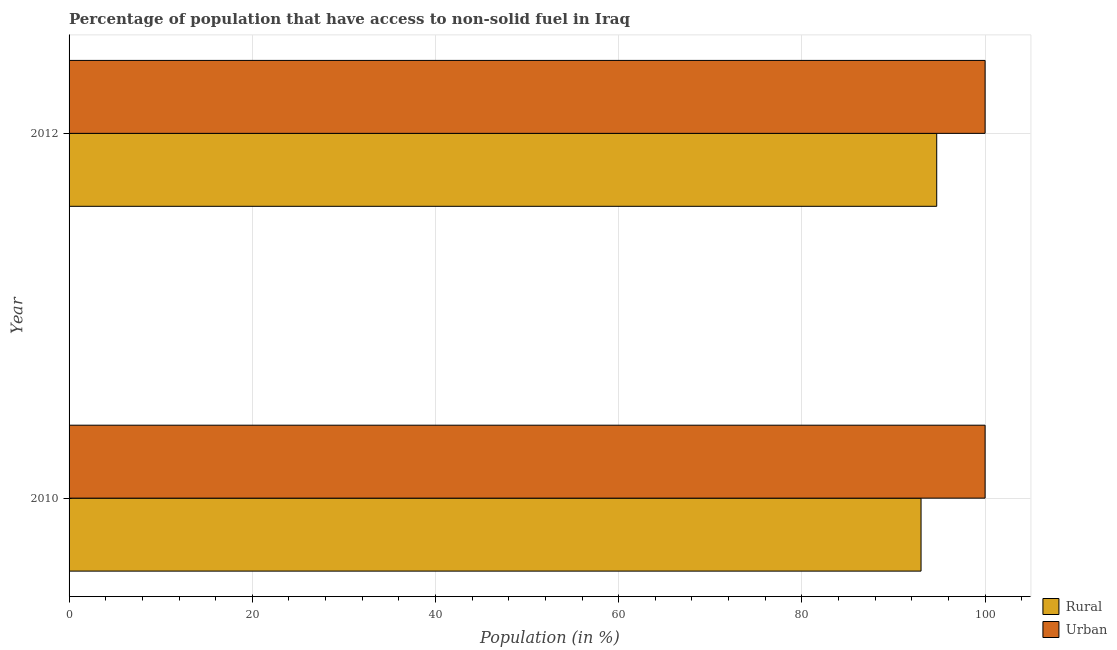How many different coloured bars are there?
Give a very brief answer. 2. How many groups of bars are there?
Make the answer very short. 2. Are the number of bars per tick equal to the number of legend labels?
Keep it short and to the point. Yes. Are the number of bars on each tick of the Y-axis equal?
Keep it short and to the point. Yes. In how many cases, is the number of bars for a given year not equal to the number of legend labels?
Give a very brief answer. 0. What is the urban population in 2012?
Provide a short and direct response. 100. Across all years, what is the maximum rural population?
Ensure brevity in your answer.  94.72. Across all years, what is the minimum urban population?
Provide a short and direct response. 100. In which year was the rural population minimum?
Offer a terse response. 2010. What is the total urban population in the graph?
Your response must be concise. 200. What is the difference between the rural population in 2010 and that in 2012?
Offer a terse response. -1.71. What is the difference between the rural population in 2010 and the urban population in 2012?
Make the answer very short. -6.99. In the year 2010, what is the difference between the urban population and rural population?
Give a very brief answer. 6.99. In how many years, is the rural population greater than 60 %?
Your answer should be compact. 2. What is the ratio of the rural population in 2010 to that in 2012?
Give a very brief answer. 0.98. Is the urban population in 2010 less than that in 2012?
Your answer should be very brief. No. In how many years, is the rural population greater than the average rural population taken over all years?
Your answer should be compact. 1. What does the 2nd bar from the top in 2010 represents?
Offer a terse response. Rural. What does the 2nd bar from the bottom in 2012 represents?
Offer a very short reply. Urban. How many bars are there?
Provide a succinct answer. 4. Does the graph contain grids?
Provide a short and direct response. Yes. How many legend labels are there?
Your answer should be very brief. 2. What is the title of the graph?
Keep it short and to the point. Percentage of population that have access to non-solid fuel in Iraq. Does "Female labourers" appear as one of the legend labels in the graph?
Your answer should be compact. No. What is the label or title of the X-axis?
Provide a succinct answer. Population (in %). What is the Population (in %) of Rural in 2010?
Your answer should be compact. 93.01. What is the Population (in %) of Urban in 2010?
Offer a terse response. 100. What is the Population (in %) of Rural in 2012?
Ensure brevity in your answer.  94.72. What is the Population (in %) in Urban in 2012?
Offer a very short reply. 100. Across all years, what is the maximum Population (in %) in Rural?
Provide a succinct answer. 94.72. Across all years, what is the minimum Population (in %) of Rural?
Your answer should be very brief. 93.01. What is the total Population (in %) of Rural in the graph?
Make the answer very short. 187.72. What is the total Population (in %) of Urban in the graph?
Offer a very short reply. 200. What is the difference between the Population (in %) of Rural in 2010 and that in 2012?
Your answer should be very brief. -1.71. What is the difference between the Population (in %) in Urban in 2010 and that in 2012?
Offer a very short reply. 0. What is the difference between the Population (in %) of Rural in 2010 and the Population (in %) of Urban in 2012?
Ensure brevity in your answer.  -6.99. What is the average Population (in %) of Rural per year?
Your response must be concise. 93.86. What is the average Population (in %) in Urban per year?
Offer a very short reply. 100. In the year 2010, what is the difference between the Population (in %) in Rural and Population (in %) in Urban?
Keep it short and to the point. -6.99. In the year 2012, what is the difference between the Population (in %) in Rural and Population (in %) in Urban?
Give a very brief answer. -5.28. What is the ratio of the Population (in %) in Rural in 2010 to that in 2012?
Provide a succinct answer. 0.98. What is the difference between the highest and the second highest Population (in %) of Rural?
Provide a short and direct response. 1.71. What is the difference between the highest and the second highest Population (in %) of Urban?
Offer a terse response. 0. What is the difference between the highest and the lowest Population (in %) in Rural?
Keep it short and to the point. 1.71. What is the difference between the highest and the lowest Population (in %) of Urban?
Keep it short and to the point. 0. 